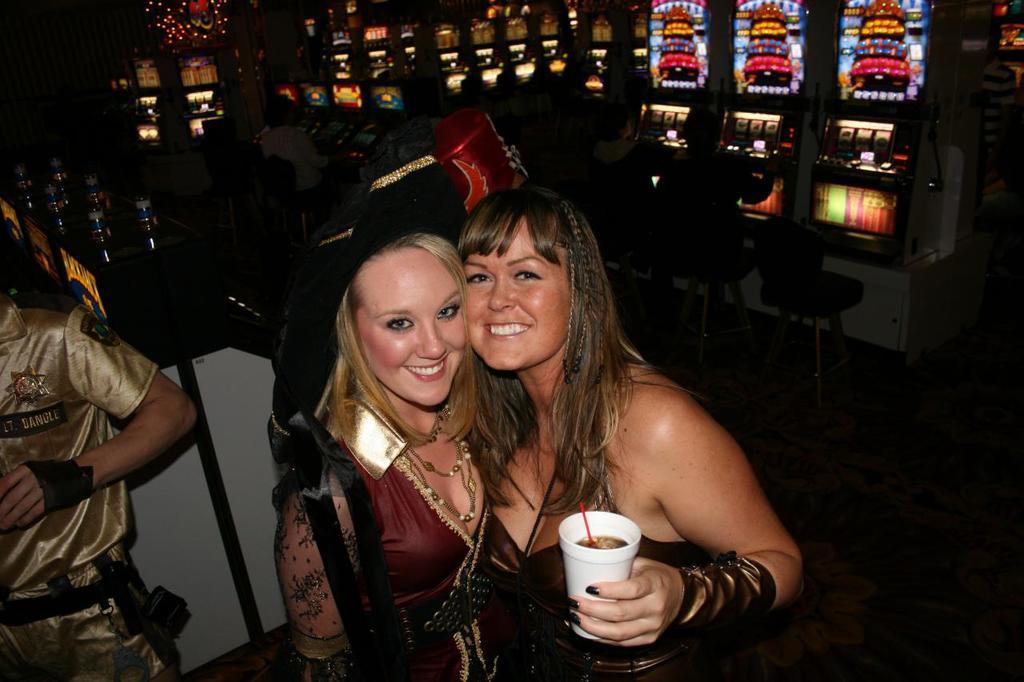Please provide a concise description of this image. In this image in the front there are women standing and smiling and on the right side there are colourful objects and there are persons sitting. On the left side there is a person standing. In the background there are bottles and there are lights. In the front on the right side there is a woman standing and smiling and holding a glass in her hand which is white in colour. 